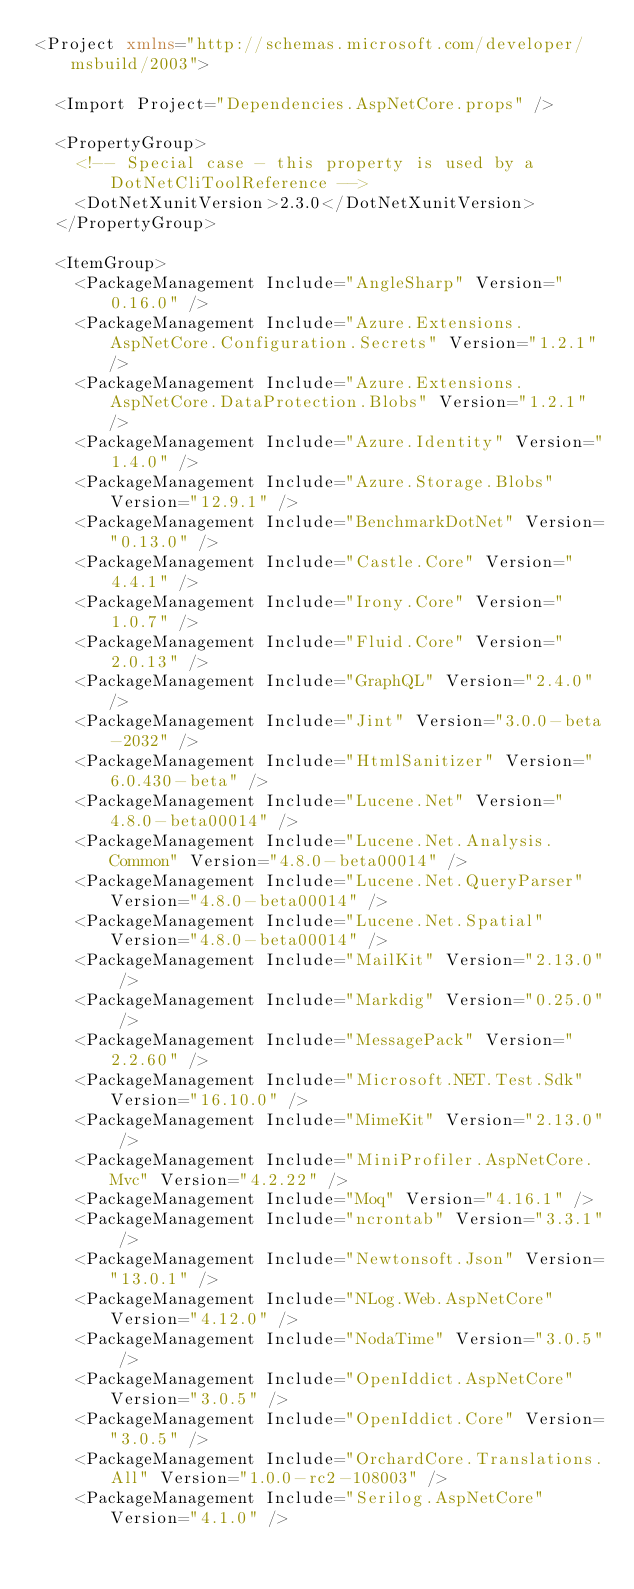Convert code to text. <code><loc_0><loc_0><loc_500><loc_500><_XML_><Project xmlns="http://schemas.microsoft.com/developer/msbuild/2003">

  <Import Project="Dependencies.AspNetCore.props" />

  <PropertyGroup>
    <!-- Special case - this property is used by a DotNetCliToolReference -->
    <DotNetXunitVersion>2.3.0</DotNetXunitVersion>
  </PropertyGroup>

  <ItemGroup>
    <PackageManagement Include="AngleSharp" Version="0.16.0" />
    <PackageManagement Include="Azure.Extensions.AspNetCore.Configuration.Secrets" Version="1.2.1" />
    <PackageManagement Include="Azure.Extensions.AspNetCore.DataProtection.Blobs" Version="1.2.1" />
    <PackageManagement Include="Azure.Identity" Version="1.4.0" />
    <PackageManagement Include="Azure.Storage.Blobs" Version="12.9.1" />
    <PackageManagement Include="BenchmarkDotNet" Version="0.13.0" />
    <PackageManagement Include="Castle.Core" Version="4.4.1" />
    <PackageManagement Include="Irony.Core" Version="1.0.7" />
    <PackageManagement Include="Fluid.Core" Version="2.0.13" />
    <PackageManagement Include="GraphQL" Version="2.4.0" />
    <PackageManagement Include="Jint" Version="3.0.0-beta-2032" />
    <PackageManagement Include="HtmlSanitizer" Version="6.0.430-beta" />
    <PackageManagement Include="Lucene.Net" Version="4.8.0-beta00014" />
    <PackageManagement Include="Lucene.Net.Analysis.Common" Version="4.8.0-beta00014" />
    <PackageManagement Include="Lucene.Net.QueryParser" Version="4.8.0-beta00014" />
    <PackageManagement Include="Lucene.Net.Spatial" Version="4.8.0-beta00014" />
    <PackageManagement Include="MailKit" Version="2.13.0" />
    <PackageManagement Include="Markdig" Version="0.25.0" />
    <PackageManagement Include="MessagePack" Version="2.2.60" />
    <PackageManagement Include="Microsoft.NET.Test.Sdk" Version="16.10.0" />
    <PackageManagement Include="MimeKit" Version="2.13.0" />
    <PackageManagement Include="MiniProfiler.AspNetCore.Mvc" Version="4.2.22" />
    <PackageManagement Include="Moq" Version="4.16.1" />
    <PackageManagement Include="ncrontab" Version="3.3.1" />
    <PackageManagement Include="Newtonsoft.Json" Version="13.0.1" />
    <PackageManagement Include="NLog.Web.AspNetCore" Version="4.12.0" />
    <PackageManagement Include="NodaTime" Version="3.0.5" />
    <PackageManagement Include="OpenIddict.AspNetCore" Version="3.0.5" />
    <PackageManagement Include="OpenIddict.Core" Version="3.0.5" />
    <PackageManagement Include="OrchardCore.Translations.All" Version="1.0.0-rc2-108003" />
    <PackageManagement Include="Serilog.AspNetCore" Version="4.1.0" /></code> 